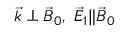<formula> <loc_0><loc_0><loc_500><loc_500>{ \vec { k } } \perp { \vec { B } } _ { 0 } , \ { \vec { E } } _ { 1 } \| { \vec { B } } _ { 0 }</formula> 